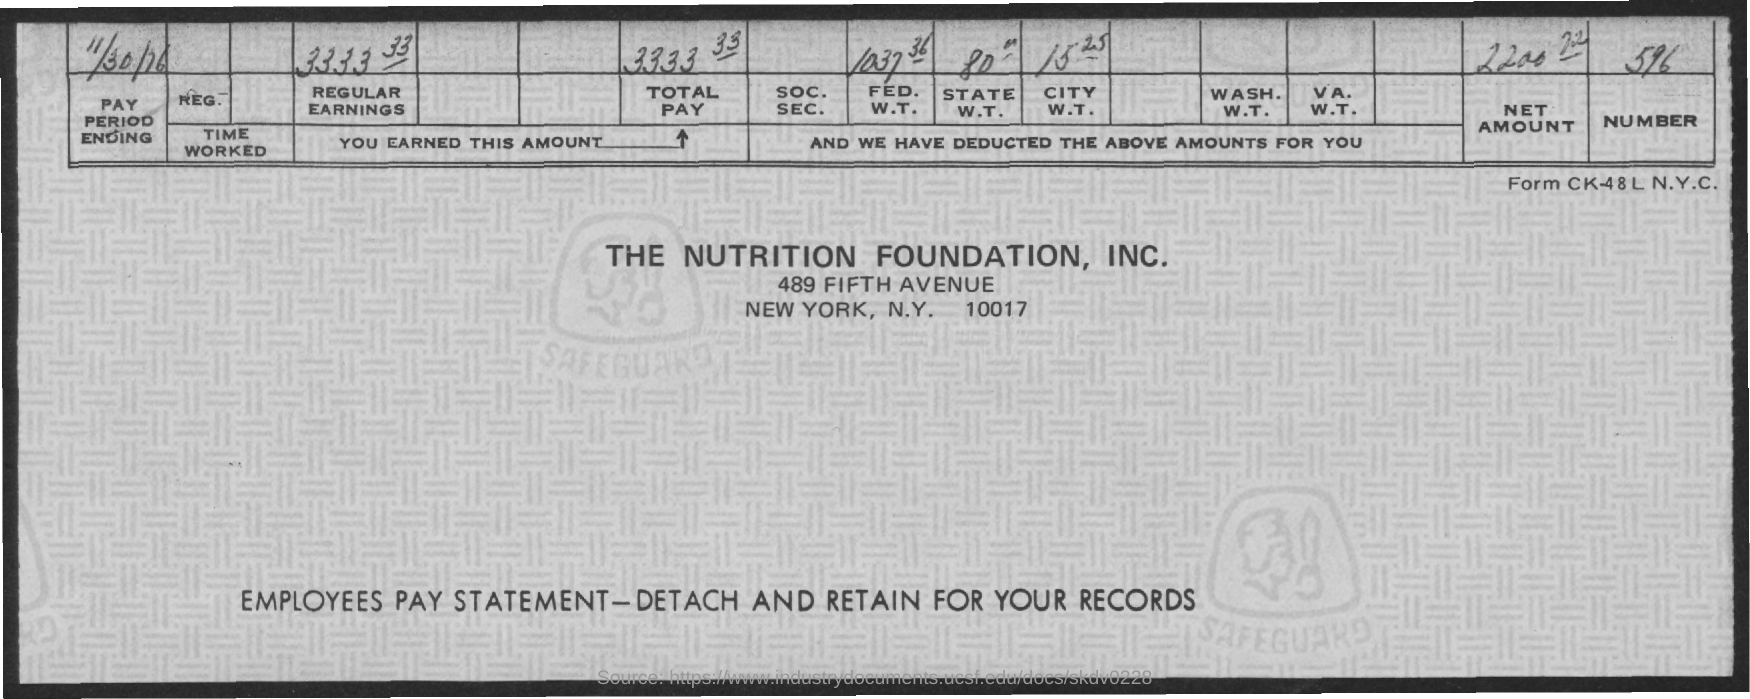When is the Pay period ending?
Offer a very short reply. 11/30/76. What is the total pay?
Offer a terse response. 3333.33. What is the FED. W.T.?
Offer a terse response. 1037 36. What is the City W.T.?
Keep it short and to the point. 15.25. What is the Net Amount?
Offer a very short reply. 2200 72. What is the Number?
Provide a succinct answer. 596. 